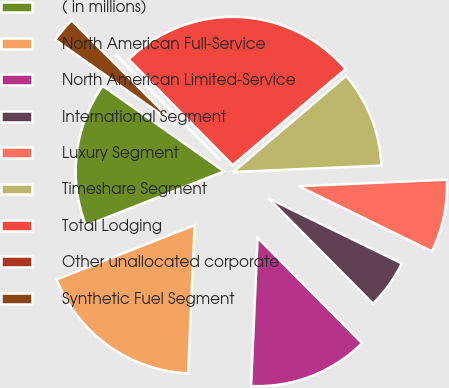<chart> <loc_0><loc_0><loc_500><loc_500><pie_chart><fcel>( in millions)<fcel>North American Full-Service<fcel>North American Limited-Service<fcel>International Segment<fcel>Luxury Segment<fcel>Timeshare Segment<fcel>Total Lodging<fcel>Other unallocated corporate<fcel>Synthetic Fuel Segment<nl><fcel>15.73%<fcel>18.33%<fcel>13.13%<fcel>5.33%<fcel>7.93%<fcel>10.53%<fcel>26.13%<fcel>0.13%<fcel>2.73%<nl></chart> 